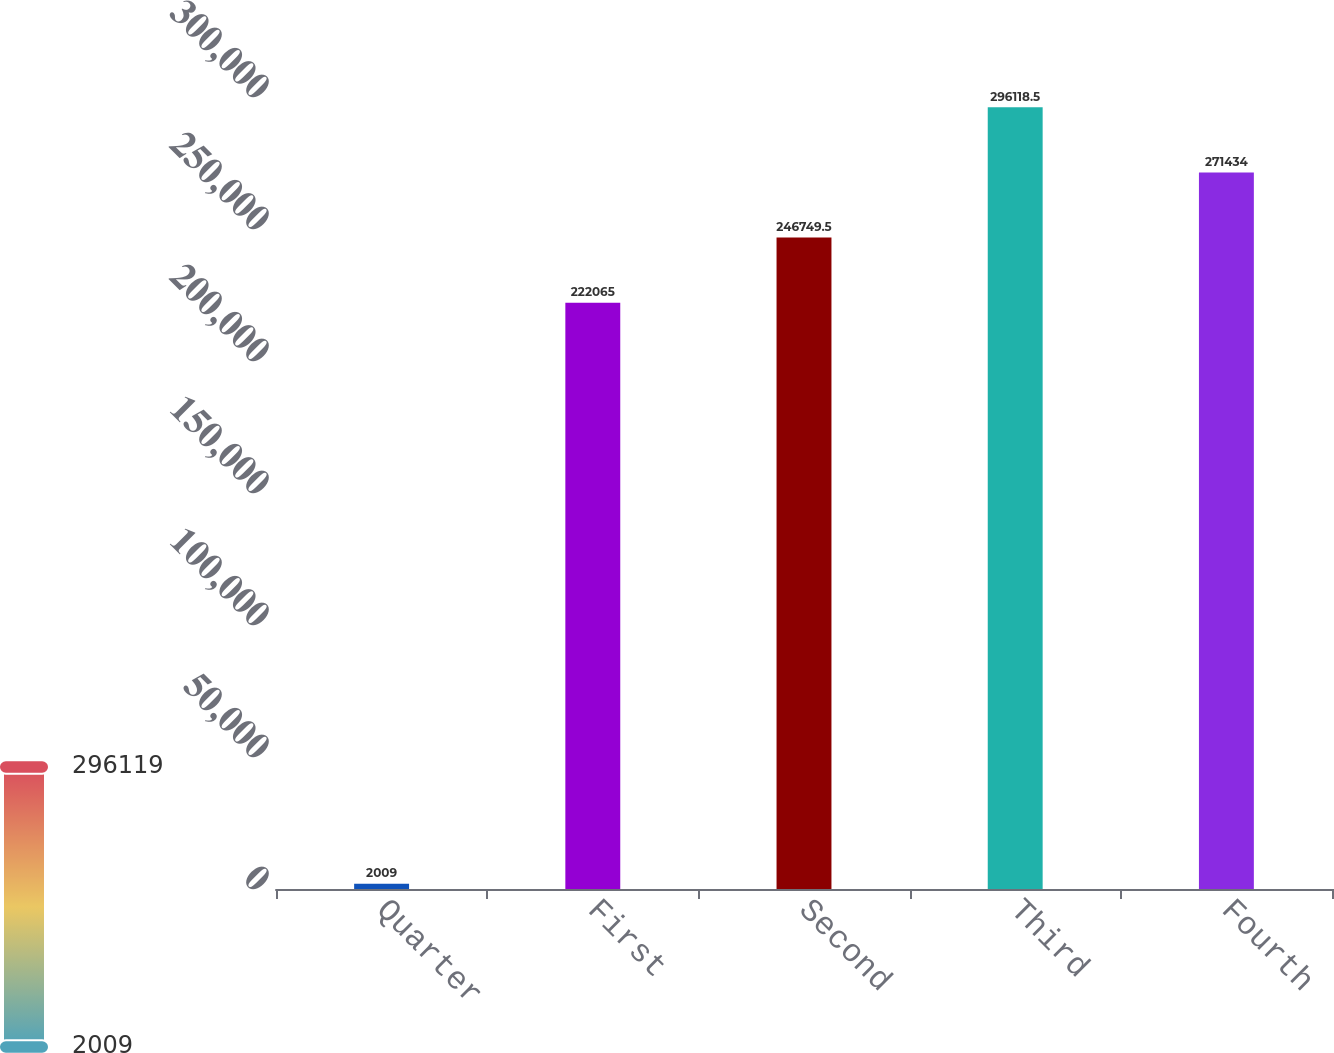Convert chart to OTSL. <chart><loc_0><loc_0><loc_500><loc_500><bar_chart><fcel>Quarter<fcel>First<fcel>Second<fcel>Third<fcel>Fourth<nl><fcel>2009<fcel>222065<fcel>246750<fcel>296118<fcel>271434<nl></chart> 